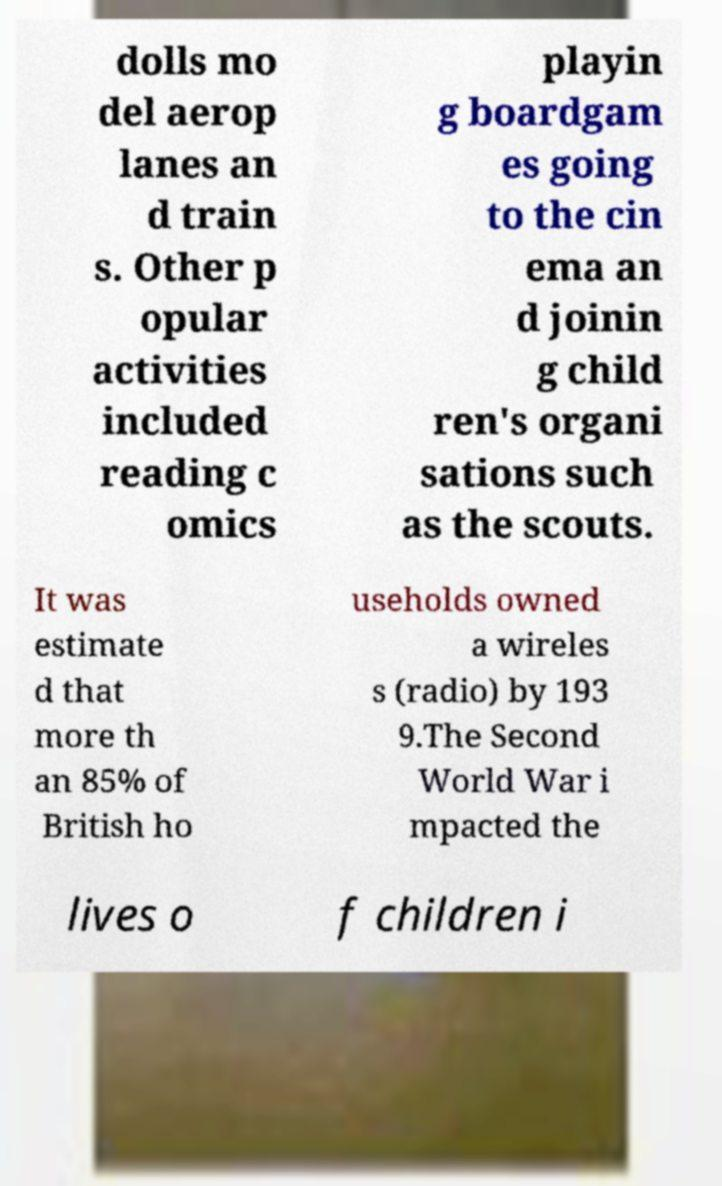Please identify and transcribe the text found in this image. dolls mo del aerop lanes an d train s. Other p opular activities included reading c omics playin g boardgam es going to the cin ema an d joinin g child ren's organi sations such as the scouts. It was estimate d that more th an 85% of British ho useholds owned a wireles s (radio) by 193 9.The Second World War i mpacted the lives o f children i 